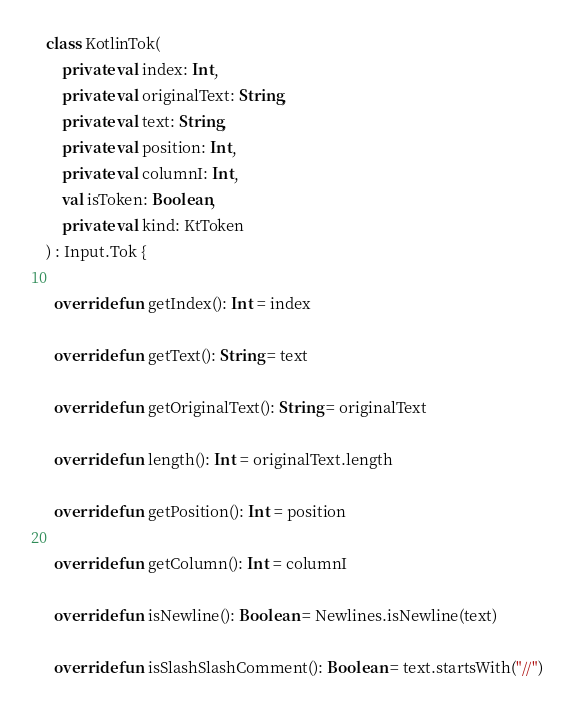<code> <loc_0><loc_0><loc_500><loc_500><_Kotlin_>class KotlinTok(
    private val index: Int,
    private val originalText: String,
    private val text: String,
    private val position: Int,
    private val columnI: Int,
    val isToken: Boolean,
    private val kind: KtToken
) : Input.Tok {

  override fun getIndex(): Int = index

  override fun getText(): String = text

  override fun getOriginalText(): String = originalText

  override fun length(): Int = originalText.length

  override fun getPosition(): Int = position

  override fun getColumn(): Int = columnI

  override fun isNewline(): Boolean = Newlines.isNewline(text)

  override fun isSlashSlashComment(): Boolean = text.startsWith("//")
</code> 